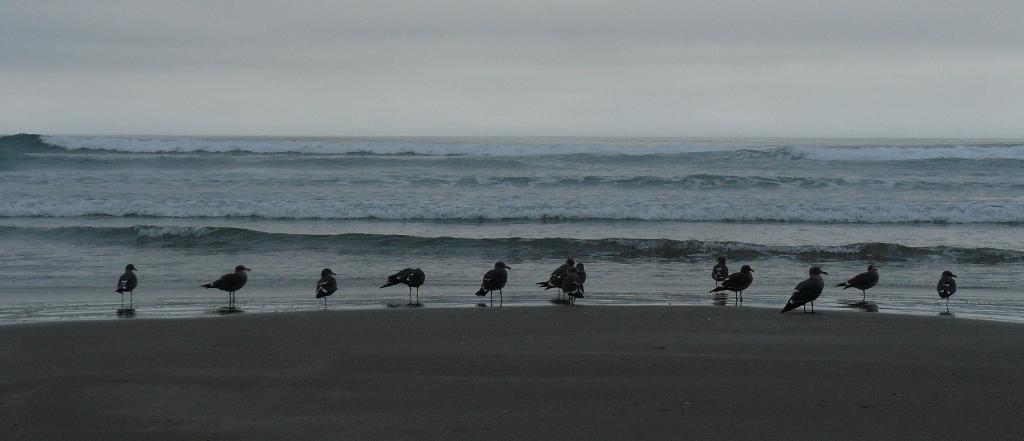What type of animals can be seen in the image? There are birds in the image. What natural feature is visible in the background of the image? The sea is visible in the image. What else can be seen in the sky in the image? The sky is visible in the image. What type of flowers can be seen growing near the birds in the image? There are no flowers visible in the image; it features birds and a natural landscape. 